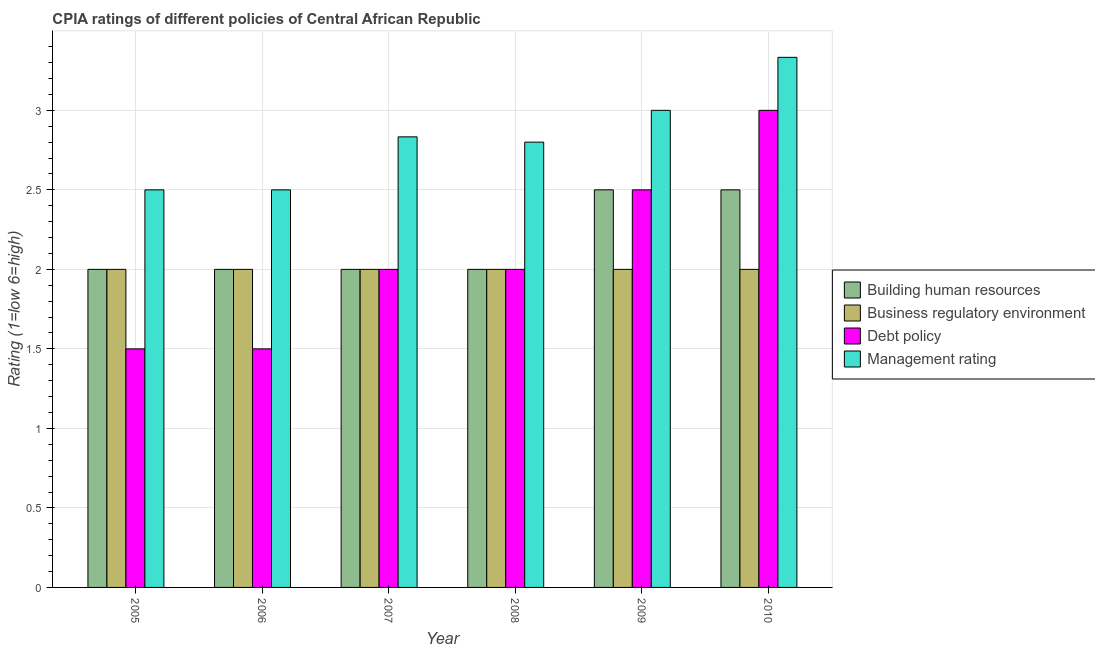How many different coloured bars are there?
Provide a short and direct response. 4. Are the number of bars on each tick of the X-axis equal?
Make the answer very short. Yes. How many bars are there on the 4th tick from the right?
Keep it short and to the point. 4. What is the cpia rating of business regulatory environment in 2005?
Give a very brief answer. 2. Across all years, what is the minimum cpia rating of management?
Your response must be concise. 2.5. In which year was the cpia rating of building human resources minimum?
Keep it short and to the point. 2005. What is the difference between the cpia rating of building human resources in 2007 and that in 2008?
Give a very brief answer. 0. What is the average cpia rating of management per year?
Keep it short and to the point. 2.83. In the year 2008, what is the difference between the cpia rating of building human resources and cpia rating of debt policy?
Your response must be concise. 0. What is the ratio of the cpia rating of management in 2007 to that in 2010?
Make the answer very short. 0.85. Is the cpia rating of debt policy in 2006 less than that in 2009?
Provide a short and direct response. Yes. Is the difference between the cpia rating of management in 2005 and 2009 greater than the difference between the cpia rating of business regulatory environment in 2005 and 2009?
Ensure brevity in your answer.  No. What is the difference between the highest and the lowest cpia rating of management?
Your response must be concise. 0.83. What does the 2nd bar from the left in 2005 represents?
Ensure brevity in your answer.  Business regulatory environment. What does the 3rd bar from the right in 2007 represents?
Your answer should be compact. Business regulatory environment. How many years are there in the graph?
Make the answer very short. 6. How many legend labels are there?
Your answer should be very brief. 4. What is the title of the graph?
Make the answer very short. CPIA ratings of different policies of Central African Republic. What is the label or title of the X-axis?
Keep it short and to the point. Year. What is the label or title of the Y-axis?
Keep it short and to the point. Rating (1=low 6=high). What is the Rating (1=low 6=high) in Building human resources in 2005?
Offer a very short reply. 2. What is the Rating (1=low 6=high) in Business regulatory environment in 2005?
Give a very brief answer. 2. What is the Rating (1=low 6=high) of Debt policy in 2005?
Your response must be concise. 1.5. What is the Rating (1=low 6=high) of Management rating in 2005?
Keep it short and to the point. 2.5. What is the Rating (1=low 6=high) in Building human resources in 2006?
Offer a very short reply. 2. What is the Rating (1=low 6=high) of Management rating in 2006?
Your response must be concise. 2.5. What is the Rating (1=low 6=high) in Building human resources in 2007?
Keep it short and to the point. 2. What is the Rating (1=low 6=high) of Management rating in 2007?
Offer a terse response. 2.83. What is the Rating (1=low 6=high) of Building human resources in 2008?
Ensure brevity in your answer.  2. What is the Rating (1=low 6=high) of Management rating in 2008?
Ensure brevity in your answer.  2.8. What is the Rating (1=low 6=high) of Building human resources in 2009?
Provide a succinct answer. 2.5. What is the Rating (1=low 6=high) in Management rating in 2009?
Provide a succinct answer. 3. What is the Rating (1=low 6=high) in Business regulatory environment in 2010?
Provide a short and direct response. 2. What is the Rating (1=low 6=high) in Management rating in 2010?
Make the answer very short. 3.33. Across all years, what is the maximum Rating (1=low 6=high) of Building human resources?
Your answer should be compact. 2.5. Across all years, what is the maximum Rating (1=low 6=high) of Debt policy?
Your response must be concise. 3. Across all years, what is the maximum Rating (1=low 6=high) in Management rating?
Give a very brief answer. 3.33. Across all years, what is the minimum Rating (1=low 6=high) of Building human resources?
Make the answer very short. 2. Across all years, what is the minimum Rating (1=low 6=high) in Business regulatory environment?
Your response must be concise. 2. What is the total Rating (1=low 6=high) in Building human resources in the graph?
Keep it short and to the point. 13. What is the total Rating (1=low 6=high) in Management rating in the graph?
Give a very brief answer. 16.97. What is the difference between the Rating (1=low 6=high) of Management rating in 2005 and that in 2006?
Your answer should be very brief. 0. What is the difference between the Rating (1=low 6=high) of Debt policy in 2005 and that in 2007?
Make the answer very short. -0.5. What is the difference between the Rating (1=low 6=high) in Management rating in 2005 and that in 2007?
Your response must be concise. -0.33. What is the difference between the Rating (1=low 6=high) in Business regulatory environment in 2005 and that in 2008?
Ensure brevity in your answer.  0. What is the difference between the Rating (1=low 6=high) of Debt policy in 2005 and that in 2008?
Make the answer very short. -0.5. What is the difference between the Rating (1=low 6=high) of Building human resources in 2005 and that in 2009?
Keep it short and to the point. -0.5. What is the difference between the Rating (1=low 6=high) of Business regulatory environment in 2005 and that in 2009?
Keep it short and to the point. 0. What is the difference between the Rating (1=low 6=high) in Management rating in 2005 and that in 2009?
Give a very brief answer. -0.5. What is the difference between the Rating (1=low 6=high) in Debt policy in 2005 and that in 2010?
Keep it short and to the point. -1.5. What is the difference between the Rating (1=low 6=high) in Management rating in 2005 and that in 2010?
Ensure brevity in your answer.  -0.83. What is the difference between the Rating (1=low 6=high) of Building human resources in 2006 and that in 2007?
Offer a terse response. 0. What is the difference between the Rating (1=low 6=high) of Business regulatory environment in 2006 and that in 2007?
Your response must be concise. 0. What is the difference between the Rating (1=low 6=high) in Management rating in 2006 and that in 2007?
Your answer should be very brief. -0.33. What is the difference between the Rating (1=low 6=high) of Debt policy in 2006 and that in 2008?
Ensure brevity in your answer.  -0.5. What is the difference between the Rating (1=low 6=high) of Building human resources in 2006 and that in 2010?
Offer a terse response. -0.5. What is the difference between the Rating (1=low 6=high) of Business regulatory environment in 2006 and that in 2010?
Provide a short and direct response. 0. What is the difference between the Rating (1=low 6=high) in Debt policy in 2006 and that in 2010?
Keep it short and to the point. -1.5. What is the difference between the Rating (1=low 6=high) of Building human resources in 2007 and that in 2009?
Your response must be concise. -0.5. What is the difference between the Rating (1=low 6=high) of Business regulatory environment in 2007 and that in 2009?
Your answer should be compact. 0. What is the difference between the Rating (1=low 6=high) in Building human resources in 2007 and that in 2010?
Keep it short and to the point. -0.5. What is the difference between the Rating (1=low 6=high) of Debt policy in 2007 and that in 2010?
Provide a short and direct response. -1. What is the difference between the Rating (1=low 6=high) in Building human resources in 2008 and that in 2009?
Offer a very short reply. -0.5. What is the difference between the Rating (1=low 6=high) in Debt policy in 2008 and that in 2010?
Offer a very short reply. -1. What is the difference between the Rating (1=low 6=high) in Management rating in 2008 and that in 2010?
Ensure brevity in your answer.  -0.53. What is the difference between the Rating (1=low 6=high) in Business regulatory environment in 2009 and that in 2010?
Keep it short and to the point. 0. What is the difference between the Rating (1=low 6=high) of Debt policy in 2009 and that in 2010?
Offer a terse response. -0.5. What is the difference between the Rating (1=low 6=high) of Management rating in 2009 and that in 2010?
Provide a succinct answer. -0.33. What is the difference between the Rating (1=low 6=high) in Building human resources in 2005 and the Rating (1=low 6=high) in Debt policy in 2006?
Your answer should be very brief. 0.5. What is the difference between the Rating (1=low 6=high) of Building human resources in 2005 and the Rating (1=low 6=high) of Management rating in 2006?
Your answer should be very brief. -0.5. What is the difference between the Rating (1=low 6=high) in Business regulatory environment in 2005 and the Rating (1=low 6=high) in Debt policy in 2006?
Your answer should be compact. 0.5. What is the difference between the Rating (1=low 6=high) of Business regulatory environment in 2005 and the Rating (1=low 6=high) of Management rating in 2006?
Provide a succinct answer. -0.5. What is the difference between the Rating (1=low 6=high) of Building human resources in 2005 and the Rating (1=low 6=high) of Business regulatory environment in 2007?
Offer a terse response. 0. What is the difference between the Rating (1=low 6=high) in Building human resources in 2005 and the Rating (1=low 6=high) in Debt policy in 2007?
Provide a succinct answer. 0. What is the difference between the Rating (1=low 6=high) in Building human resources in 2005 and the Rating (1=low 6=high) in Management rating in 2007?
Provide a succinct answer. -0.83. What is the difference between the Rating (1=low 6=high) of Debt policy in 2005 and the Rating (1=low 6=high) of Management rating in 2007?
Provide a short and direct response. -1.33. What is the difference between the Rating (1=low 6=high) in Building human resources in 2005 and the Rating (1=low 6=high) in Business regulatory environment in 2008?
Provide a short and direct response. 0. What is the difference between the Rating (1=low 6=high) in Building human resources in 2005 and the Rating (1=low 6=high) in Management rating in 2008?
Offer a terse response. -0.8. What is the difference between the Rating (1=low 6=high) of Business regulatory environment in 2005 and the Rating (1=low 6=high) of Management rating in 2008?
Give a very brief answer. -0.8. What is the difference between the Rating (1=low 6=high) of Debt policy in 2005 and the Rating (1=low 6=high) of Management rating in 2008?
Provide a succinct answer. -1.3. What is the difference between the Rating (1=low 6=high) in Business regulatory environment in 2005 and the Rating (1=low 6=high) in Management rating in 2009?
Provide a succinct answer. -1. What is the difference between the Rating (1=low 6=high) in Building human resources in 2005 and the Rating (1=low 6=high) in Business regulatory environment in 2010?
Offer a very short reply. 0. What is the difference between the Rating (1=low 6=high) of Building human resources in 2005 and the Rating (1=low 6=high) of Management rating in 2010?
Provide a succinct answer. -1.33. What is the difference between the Rating (1=low 6=high) in Business regulatory environment in 2005 and the Rating (1=low 6=high) in Debt policy in 2010?
Your response must be concise. -1. What is the difference between the Rating (1=low 6=high) in Business regulatory environment in 2005 and the Rating (1=low 6=high) in Management rating in 2010?
Your answer should be very brief. -1.33. What is the difference between the Rating (1=low 6=high) in Debt policy in 2005 and the Rating (1=low 6=high) in Management rating in 2010?
Make the answer very short. -1.83. What is the difference between the Rating (1=low 6=high) in Building human resources in 2006 and the Rating (1=low 6=high) in Business regulatory environment in 2007?
Offer a terse response. 0. What is the difference between the Rating (1=low 6=high) in Building human resources in 2006 and the Rating (1=low 6=high) in Debt policy in 2007?
Provide a succinct answer. 0. What is the difference between the Rating (1=low 6=high) in Business regulatory environment in 2006 and the Rating (1=low 6=high) in Debt policy in 2007?
Give a very brief answer. 0. What is the difference between the Rating (1=low 6=high) of Business regulatory environment in 2006 and the Rating (1=low 6=high) of Management rating in 2007?
Your response must be concise. -0.83. What is the difference between the Rating (1=low 6=high) in Debt policy in 2006 and the Rating (1=low 6=high) in Management rating in 2007?
Ensure brevity in your answer.  -1.33. What is the difference between the Rating (1=low 6=high) in Building human resources in 2006 and the Rating (1=low 6=high) in Business regulatory environment in 2008?
Offer a very short reply. 0. What is the difference between the Rating (1=low 6=high) of Building human resources in 2006 and the Rating (1=low 6=high) of Debt policy in 2008?
Keep it short and to the point. 0. What is the difference between the Rating (1=low 6=high) of Business regulatory environment in 2006 and the Rating (1=low 6=high) of Management rating in 2008?
Make the answer very short. -0.8. What is the difference between the Rating (1=low 6=high) of Debt policy in 2006 and the Rating (1=low 6=high) of Management rating in 2008?
Provide a short and direct response. -1.3. What is the difference between the Rating (1=low 6=high) in Building human resources in 2006 and the Rating (1=low 6=high) in Business regulatory environment in 2009?
Your answer should be compact. 0. What is the difference between the Rating (1=low 6=high) of Building human resources in 2006 and the Rating (1=low 6=high) of Management rating in 2009?
Offer a very short reply. -1. What is the difference between the Rating (1=low 6=high) in Business regulatory environment in 2006 and the Rating (1=low 6=high) in Debt policy in 2009?
Offer a very short reply. -0.5. What is the difference between the Rating (1=low 6=high) in Debt policy in 2006 and the Rating (1=low 6=high) in Management rating in 2009?
Your response must be concise. -1.5. What is the difference between the Rating (1=low 6=high) of Building human resources in 2006 and the Rating (1=low 6=high) of Business regulatory environment in 2010?
Your answer should be compact. 0. What is the difference between the Rating (1=low 6=high) of Building human resources in 2006 and the Rating (1=low 6=high) of Management rating in 2010?
Your response must be concise. -1.33. What is the difference between the Rating (1=low 6=high) in Business regulatory environment in 2006 and the Rating (1=low 6=high) in Debt policy in 2010?
Offer a terse response. -1. What is the difference between the Rating (1=low 6=high) of Business regulatory environment in 2006 and the Rating (1=low 6=high) of Management rating in 2010?
Give a very brief answer. -1.33. What is the difference between the Rating (1=low 6=high) of Debt policy in 2006 and the Rating (1=low 6=high) of Management rating in 2010?
Give a very brief answer. -1.83. What is the difference between the Rating (1=low 6=high) in Building human resources in 2007 and the Rating (1=low 6=high) in Debt policy in 2008?
Give a very brief answer. 0. What is the difference between the Rating (1=low 6=high) of Building human resources in 2007 and the Rating (1=low 6=high) of Management rating in 2008?
Your answer should be compact. -0.8. What is the difference between the Rating (1=low 6=high) of Business regulatory environment in 2007 and the Rating (1=low 6=high) of Debt policy in 2008?
Your answer should be compact. 0. What is the difference between the Rating (1=low 6=high) of Business regulatory environment in 2007 and the Rating (1=low 6=high) of Management rating in 2008?
Provide a succinct answer. -0.8. What is the difference between the Rating (1=low 6=high) in Building human resources in 2007 and the Rating (1=low 6=high) in Debt policy in 2009?
Provide a short and direct response. -0.5. What is the difference between the Rating (1=low 6=high) in Building human resources in 2007 and the Rating (1=low 6=high) in Management rating in 2009?
Give a very brief answer. -1. What is the difference between the Rating (1=low 6=high) of Business regulatory environment in 2007 and the Rating (1=low 6=high) of Management rating in 2009?
Offer a very short reply. -1. What is the difference between the Rating (1=low 6=high) in Building human resources in 2007 and the Rating (1=low 6=high) in Business regulatory environment in 2010?
Your answer should be very brief. 0. What is the difference between the Rating (1=low 6=high) in Building human resources in 2007 and the Rating (1=low 6=high) in Management rating in 2010?
Provide a short and direct response. -1.33. What is the difference between the Rating (1=low 6=high) of Business regulatory environment in 2007 and the Rating (1=low 6=high) of Management rating in 2010?
Provide a short and direct response. -1.33. What is the difference between the Rating (1=low 6=high) of Debt policy in 2007 and the Rating (1=low 6=high) of Management rating in 2010?
Your response must be concise. -1.33. What is the difference between the Rating (1=low 6=high) in Building human resources in 2008 and the Rating (1=low 6=high) in Debt policy in 2009?
Your answer should be compact. -0.5. What is the difference between the Rating (1=low 6=high) in Building human resources in 2008 and the Rating (1=low 6=high) in Management rating in 2010?
Offer a very short reply. -1.33. What is the difference between the Rating (1=low 6=high) of Business regulatory environment in 2008 and the Rating (1=low 6=high) of Debt policy in 2010?
Offer a very short reply. -1. What is the difference between the Rating (1=low 6=high) of Business regulatory environment in 2008 and the Rating (1=low 6=high) of Management rating in 2010?
Offer a very short reply. -1.33. What is the difference between the Rating (1=low 6=high) of Debt policy in 2008 and the Rating (1=low 6=high) of Management rating in 2010?
Give a very brief answer. -1.33. What is the difference between the Rating (1=low 6=high) in Building human resources in 2009 and the Rating (1=low 6=high) in Business regulatory environment in 2010?
Offer a terse response. 0.5. What is the difference between the Rating (1=low 6=high) of Business regulatory environment in 2009 and the Rating (1=low 6=high) of Management rating in 2010?
Provide a succinct answer. -1.33. What is the average Rating (1=low 6=high) of Building human resources per year?
Your response must be concise. 2.17. What is the average Rating (1=low 6=high) in Debt policy per year?
Your response must be concise. 2.08. What is the average Rating (1=low 6=high) of Management rating per year?
Your response must be concise. 2.83. In the year 2005, what is the difference between the Rating (1=low 6=high) of Building human resources and Rating (1=low 6=high) of Business regulatory environment?
Keep it short and to the point. 0. In the year 2005, what is the difference between the Rating (1=low 6=high) in Business regulatory environment and Rating (1=low 6=high) in Debt policy?
Ensure brevity in your answer.  0.5. In the year 2005, what is the difference between the Rating (1=low 6=high) of Business regulatory environment and Rating (1=low 6=high) of Management rating?
Ensure brevity in your answer.  -0.5. In the year 2006, what is the difference between the Rating (1=low 6=high) in Building human resources and Rating (1=low 6=high) in Business regulatory environment?
Ensure brevity in your answer.  0. In the year 2006, what is the difference between the Rating (1=low 6=high) in Building human resources and Rating (1=low 6=high) in Management rating?
Offer a very short reply. -0.5. In the year 2006, what is the difference between the Rating (1=low 6=high) in Business regulatory environment and Rating (1=low 6=high) in Management rating?
Provide a short and direct response. -0.5. In the year 2006, what is the difference between the Rating (1=low 6=high) of Debt policy and Rating (1=low 6=high) of Management rating?
Ensure brevity in your answer.  -1. In the year 2007, what is the difference between the Rating (1=low 6=high) in Business regulatory environment and Rating (1=low 6=high) in Debt policy?
Ensure brevity in your answer.  0. In the year 2007, what is the difference between the Rating (1=low 6=high) in Business regulatory environment and Rating (1=low 6=high) in Management rating?
Make the answer very short. -0.83. In the year 2007, what is the difference between the Rating (1=low 6=high) in Debt policy and Rating (1=low 6=high) in Management rating?
Offer a terse response. -0.83. In the year 2008, what is the difference between the Rating (1=low 6=high) in Building human resources and Rating (1=low 6=high) in Debt policy?
Your answer should be very brief. 0. In the year 2008, what is the difference between the Rating (1=low 6=high) in Business regulatory environment and Rating (1=low 6=high) in Debt policy?
Offer a very short reply. 0. In the year 2008, what is the difference between the Rating (1=low 6=high) in Business regulatory environment and Rating (1=low 6=high) in Management rating?
Provide a short and direct response. -0.8. In the year 2008, what is the difference between the Rating (1=low 6=high) of Debt policy and Rating (1=low 6=high) of Management rating?
Give a very brief answer. -0.8. In the year 2009, what is the difference between the Rating (1=low 6=high) of Building human resources and Rating (1=low 6=high) of Business regulatory environment?
Your answer should be compact. 0.5. In the year 2009, what is the difference between the Rating (1=low 6=high) of Building human resources and Rating (1=low 6=high) of Debt policy?
Provide a succinct answer. 0. In the year 2009, what is the difference between the Rating (1=low 6=high) in Business regulatory environment and Rating (1=low 6=high) in Debt policy?
Provide a short and direct response. -0.5. In the year 2009, what is the difference between the Rating (1=low 6=high) of Debt policy and Rating (1=low 6=high) of Management rating?
Offer a very short reply. -0.5. In the year 2010, what is the difference between the Rating (1=low 6=high) in Building human resources and Rating (1=low 6=high) in Debt policy?
Offer a very short reply. -0.5. In the year 2010, what is the difference between the Rating (1=low 6=high) in Building human resources and Rating (1=low 6=high) in Management rating?
Make the answer very short. -0.83. In the year 2010, what is the difference between the Rating (1=low 6=high) in Business regulatory environment and Rating (1=low 6=high) in Management rating?
Your answer should be very brief. -1.33. What is the ratio of the Rating (1=low 6=high) of Business regulatory environment in 2005 to that in 2006?
Give a very brief answer. 1. What is the ratio of the Rating (1=low 6=high) in Debt policy in 2005 to that in 2006?
Provide a short and direct response. 1. What is the ratio of the Rating (1=low 6=high) in Management rating in 2005 to that in 2006?
Keep it short and to the point. 1. What is the ratio of the Rating (1=low 6=high) in Building human resources in 2005 to that in 2007?
Offer a very short reply. 1. What is the ratio of the Rating (1=low 6=high) in Business regulatory environment in 2005 to that in 2007?
Offer a very short reply. 1. What is the ratio of the Rating (1=low 6=high) of Debt policy in 2005 to that in 2007?
Offer a very short reply. 0.75. What is the ratio of the Rating (1=low 6=high) of Management rating in 2005 to that in 2007?
Your response must be concise. 0.88. What is the ratio of the Rating (1=low 6=high) of Management rating in 2005 to that in 2008?
Make the answer very short. 0.89. What is the ratio of the Rating (1=low 6=high) in Building human resources in 2005 to that in 2009?
Keep it short and to the point. 0.8. What is the ratio of the Rating (1=low 6=high) of Business regulatory environment in 2005 to that in 2009?
Your answer should be very brief. 1. What is the ratio of the Rating (1=low 6=high) of Management rating in 2005 to that in 2009?
Your answer should be very brief. 0.83. What is the ratio of the Rating (1=low 6=high) of Building human resources in 2005 to that in 2010?
Make the answer very short. 0.8. What is the ratio of the Rating (1=low 6=high) in Management rating in 2005 to that in 2010?
Offer a very short reply. 0.75. What is the ratio of the Rating (1=low 6=high) of Business regulatory environment in 2006 to that in 2007?
Offer a terse response. 1. What is the ratio of the Rating (1=low 6=high) of Management rating in 2006 to that in 2007?
Provide a short and direct response. 0.88. What is the ratio of the Rating (1=low 6=high) of Management rating in 2006 to that in 2008?
Your response must be concise. 0.89. What is the ratio of the Rating (1=low 6=high) of Building human resources in 2006 to that in 2009?
Your answer should be very brief. 0.8. What is the ratio of the Rating (1=low 6=high) in Business regulatory environment in 2006 to that in 2009?
Offer a terse response. 1. What is the ratio of the Rating (1=low 6=high) of Management rating in 2006 to that in 2009?
Provide a succinct answer. 0.83. What is the ratio of the Rating (1=low 6=high) of Building human resources in 2006 to that in 2010?
Your response must be concise. 0.8. What is the ratio of the Rating (1=low 6=high) in Debt policy in 2006 to that in 2010?
Your response must be concise. 0.5. What is the ratio of the Rating (1=low 6=high) in Debt policy in 2007 to that in 2008?
Make the answer very short. 1. What is the ratio of the Rating (1=low 6=high) in Management rating in 2007 to that in 2008?
Your answer should be compact. 1.01. What is the ratio of the Rating (1=low 6=high) in Business regulatory environment in 2007 to that in 2009?
Provide a short and direct response. 1. What is the ratio of the Rating (1=low 6=high) of Debt policy in 2007 to that in 2009?
Offer a terse response. 0.8. What is the ratio of the Rating (1=low 6=high) of Management rating in 2007 to that in 2009?
Your response must be concise. 0.94. What is the ratio of the Rating (1=low 6=high) in Building human resources in 2007 to that in 2010?
Make the answer very short. 0.8. What is the ratio of the Rating (1=low 6=high) of Building human resources in 2008 to that in 2009?
Make the answer very short. 0.8. What is the ratio of the Rating (1=low 6=high) of Business regulatory environment in 2008 to that in 2009?
Offer a terse response. 1. What is the ratio of the Rating (1=low 6=high) in Debt policy in 2008 to that in 2009?
Your answer should be very brief. 0.8. What is the ratio of the Rating (1=low 6=high) of Building human resources in 2008 to that in 2010?
Offer a terse response. 0.8. What is the ratio of the Rating (1=low 6=high) of Business regulatory environment in 2008 to that in 2010?
Provide a short and direct response. 1. What is the ratio of the Rating (1=low 6=high) of Management rating in 2008 to that in 2010?
Keep it short and to the point. 0.84. What is the ratio of the Rating (1=low 6=high) of Building human resources in 2009 to that in 2010?
Provide a short and direct response. 1. What is the ratio of the Rating (1=low 6=high) in Debt policy in 2009 to that in 2010?
Ensure brevity in your answer.  0.83. What is the difference between the highest and the second highest Rating (1=low 6=high) in Building human resources?
Keep it short and to the point. 0. What is the difference between the highest and the second highest Rating (1=low 6=high) of Business regulatory environment?
Give a very brief answer. 0. What is the difference between the highest and the second highest Rating (1=low 6=high) of Debt policy?
Your response must be concise. 0.5. 